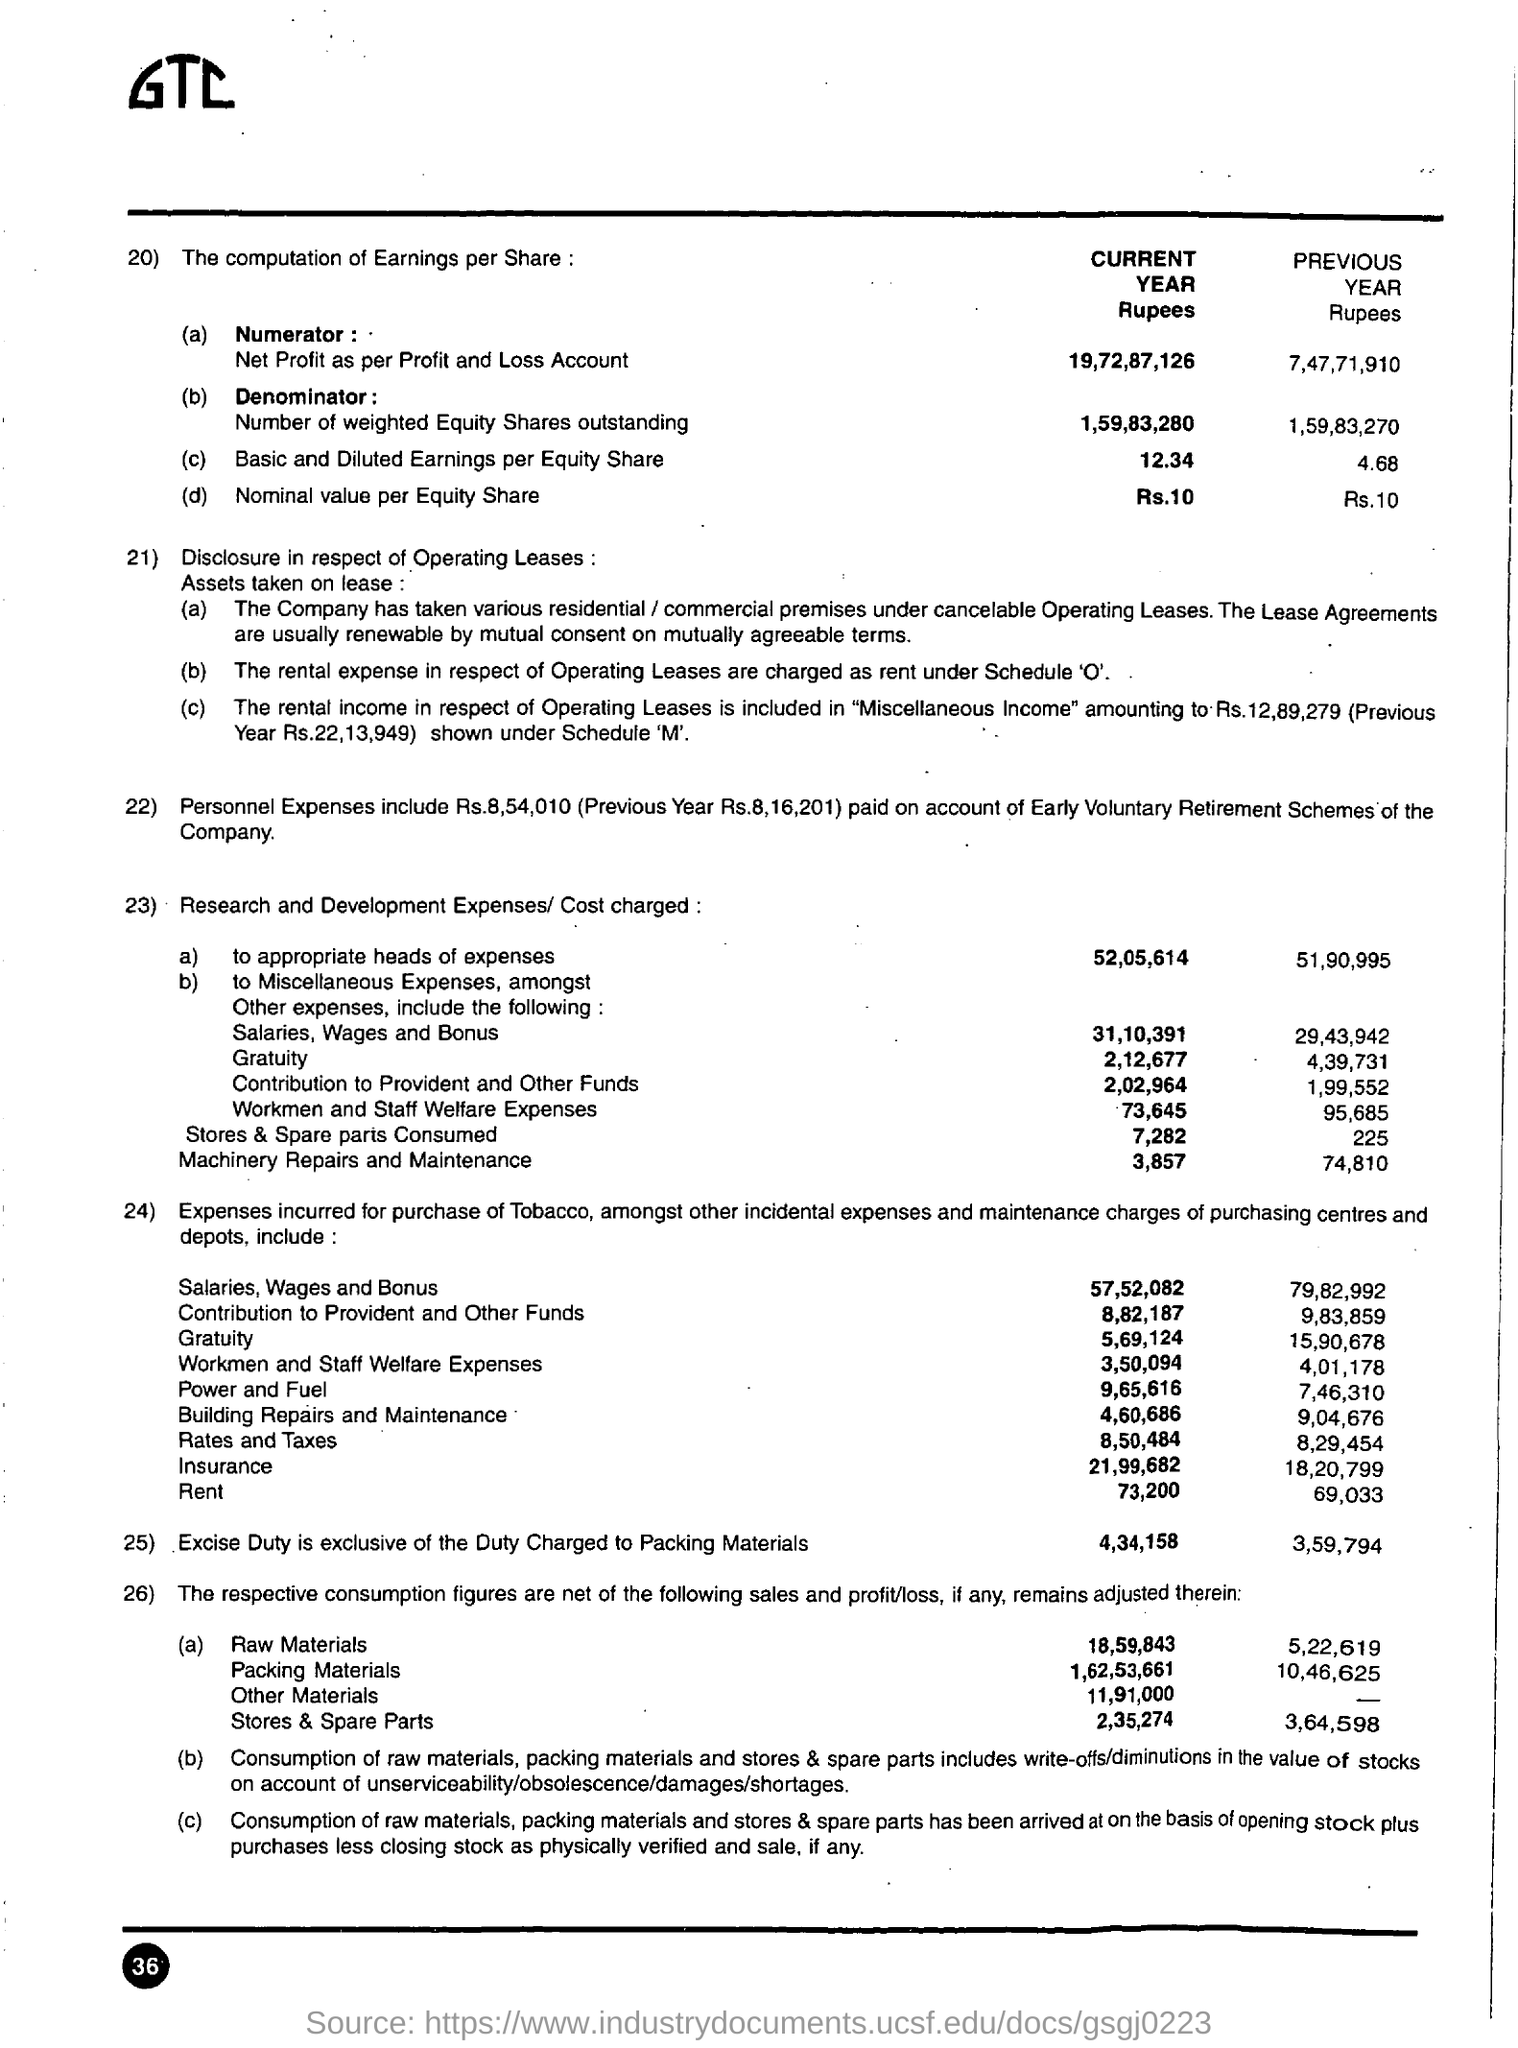Point out several critical features in this image. The first expense under the number '23' is Research and Development Expenses/Cost, which are charged to appropriate Heads of Expenses. The nominal value per equity share for the current year, assuming numbering 20, is Rs. 10. The current year has a high "Basic and Diluted Earnings per Equity Share" based on the numbering 20. 